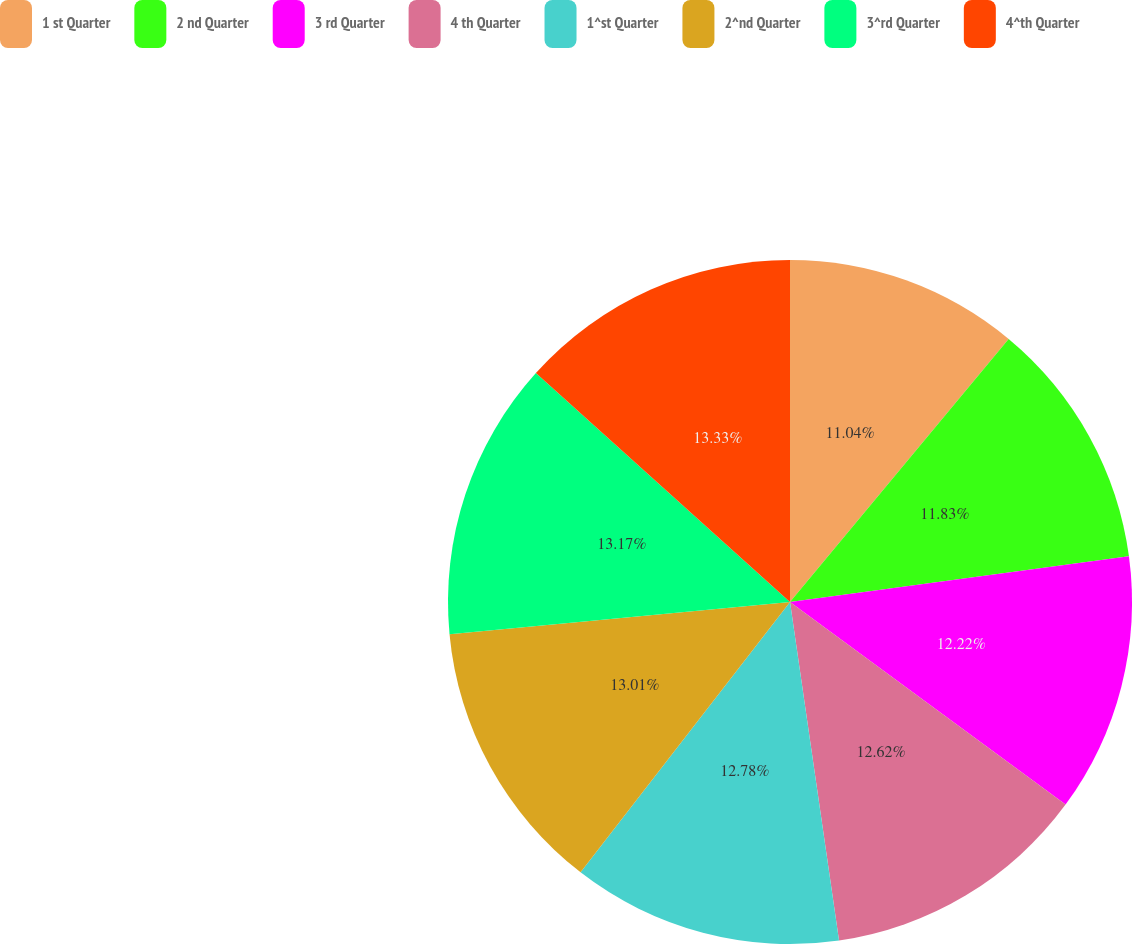<chart> <loc_0><loc_0><loc_500><loc_500><pie_chart><fcel>1 st Quarter<fcel>2 nd Quarter<fcel>3 rd Quarter<fcel>4 th Quarter<fcel>1^st Quarter<fcel>2^nd Quarter<fcel>3^rd Quarter<fcel>4^th Quarter<nl><fcel>11.04%<fcel>11.83%<fcel>12.22%<fcel>12.62%<fcel>12.78%<fcel>13.01%<fcel>13.17%<fcel>13.33%<nl></chart> 